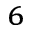<formula> <loc_0><loc_0><loc_500><loc_500>^ { 6 }</formula> 